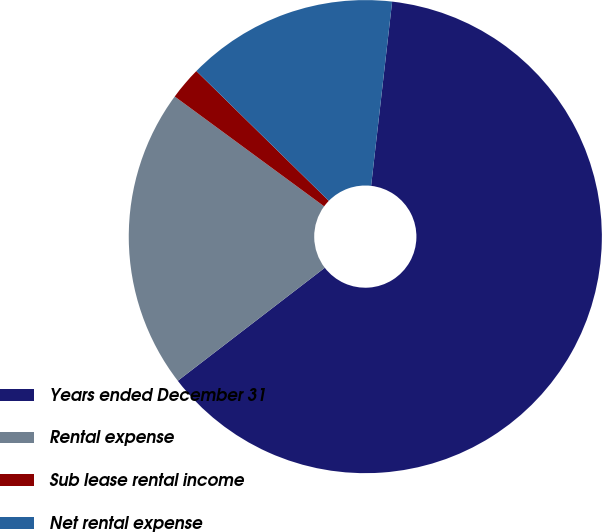<chart> <loc_0><loc_0><loc_500><loc_500><pie_chart><fcel>Years ended December 31<fcel>Rental expense<fcel>Sub lease rental income<fcel>Net rental expense<nl><fcel>62.76%<fcel>20.52%<fcel>2.25%<fcel>14.47%<nl></chart> 